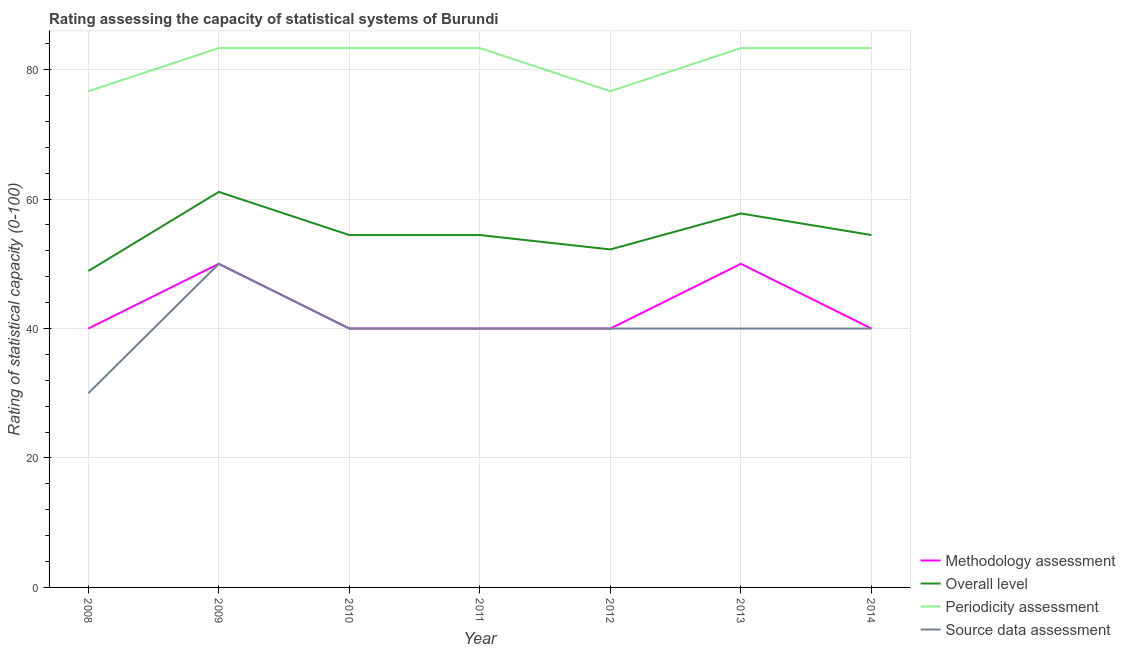How many different coloured lines are there?
Make the answer very short. 4. Does the line corresponding to periodicity assessment rating intersect with the line corresponding to source data assessment rating?
Provide a short and direct response. No. What is the overall level rating in 2012?
Ensure brevity in your answer.  52.22. Across all years, what is the maximum methodology assessment rating?
Offer a terse response. 50. Across all years, what is the minimum source data assessment rating?
Give a very brief answer. 30. In which year was the overall level rating maximum?
Provide a short and direct response. 2009. What is the total methodology assessment rating in the graph?
Provide a succinct answer. 300. What is the difference between the periodicity assessment rating in 2008 and that in 2009?
Keep it short and to the point. -6.67. What is the difference between the source data assessment rating in 2012 and the overall level rating in 2008?
Keep it short and to the point. -8.89. What is the average periodicity assessment rating per year?
Make the answer very short. 81.43. In the year 2008, what is the difference between the source data assessment rating and methodology assessment rating?
Your answer should be compact. -10. In how many years, is the methodology assessment rating greater than 64?
Your response must be concise. 0. Is the source data assessment rating in 2009 less than that in 2011?
Keep it short and to the point. No. What is the difference between the highest and the lowest source data assessment rating?
Your response must be concise. 20. In how many years, is the source data assessment rating greater than the average source data assessment rating taken over all years?
Ensure brevity in your answer.  1. Is it the case that in every year, the sum of the source data assessment rating and methodology assessment rating is greater than the sum of overall level rating and periodicity assessment rating?
Your answer should be very brief. No. Does the overall level rating monotonically increase over the years?
Keep it short and to the point. No. Is the methodology assessment rating strictly greater than the periodicity assessment rating over the years?
Provide a succinct answer. No. Is the overall level rating strictly less than the source data assessment rating over the years?
Make the answer very short. No. Does the graph contain any zero values?
Make the answer very short. No. How many legend labels are there?
Offer a very short reply. 4. What is the title of the graph?
Provide a short and direct response. Rating assessing the capacity of statistical systems of Burundi. Does "Secondary schools" appear as one of the legend labels in the graph?
Your answer should be very brief. No. What is the label or title of the Y-axis?
Offer a very short reply. Rating of statistical capacity (0-100). What is the Rating of statistical capacity (0-100) in Methodology assessment in 2008?
Your answer should be compact. 40. What is the Rating of statistical capacity (0-100) in Overall level in 2008?
Provide a succinct answer. 48.89. What is the Rating of statistical capacity (0-100) in Periodicity assessment in 2008?
Make the answer very short. 76.67. What is the Rating of statistical capacity (0-100) of Overall level in 2009?
Provide a short and direct response. 61.11. What is the Rating of statistical capacity (0-100) in Periodicity assessment in 2009?
Give a very brief answer. 83.33. What is the Rating of statistical capacity (0-100) of Source data assessment in 2009?
Your answer should be compact. 50. What is the Rating of statistical capacity (0-100) of Methodology assessment in 2010?
Your answer should be very brief. 40. What is the Rating of statistical capacity (0-100) of Overall level in 2010?
Provide a short and direct response. 54.44. What is the Rating of statistical capacity (0-100) of Periodicity assessment in 2010?
Offer a very short reply. 83.33. What is the Rating of statistical capacity (0-100) in Source data assessment in 2010?
Your answer should be very brief. 40. What is the Rating of statistical capacity (0-100) in Overall level in 2011?
Provide a succinct answer. 54.44. What is the Rating of statistical capacity (0-100) in Periodicity assessment in 2011?
Offer a very short reply. 83.33. What is the Rating of statistical capacity (0-100) of Source data assessment in 2011?
Offer a terse response. 40. What is the Rating of statistical capacity (0-100) in Methodology assessment in 2012?
Your answer should be very brief. 40. What is the Rating of statistical capacity (0-100) in Overall level in 2012?
Provide a succinct answer. 52.22. What is the Rating of statistical capacity (0-100) in Periodicity assessment in 2012?
Your response must be concise. 76.67. What is the Rating of statistical capacity (0-100) in Source data assessment in 2012?
Give a very brief answer. 40. What is the Rating of statistical capacity (0-100) of Overall level in 2013?
Give a very brief answer. 57.78. What is the Rating of statistical capacity (0-100) in Periodicity assessment in 2013?
Your answer should be compact. 83.33. What is the Rating of statistical capacity (0-100) of Source data assessment in 2013?
Keep it short and to the point. 40. What is the Rating of statistical capacity (0-100) of Overall level in 2014?
Provide a succinct answer. 54.44. What is the Rating of statistical capacity (0-100) in Periodicity assessment in 2014?
Make the answer very short. 83.33. Across all years, what is the maximum Rating of statistical capacity (0-100) in Methodology assessment?
Your answer should be compact. 50. Across all years, what is the maximum Rating of statistical capacity (0-100) of Overall level?
Provide a succinct answer. 61.11. Across all years, what is the maximum Rating of statistical capacity (0-100) in Periodicity assessment?
Give a very brief answer. 83.33. Across all years, what is the maximum Rating of statistical capacity (0-100) in Source data assessment?
Offer a terse response. 50. Across all years, what is the minimum Rating of statistical capacity (0-100) of Overall level?
Ensure brevity in your answer.  48.89. Across all years, what is the minimum Rating of statistical capacity (0-100) of Periodicity assessment?
Ensure brevity in your answer.  76.67. Across all years, what is the minimum Rating of statistical capacity (0-100) of Source data assessment?
Make the answer very short. 30. What is the total Rating of statistical capacity (0-100) in Methodology assessment in the graph?
Ensure brevity in your answer.  300. What is the total Rating of statistical capacity (0-100) of Overall level in the graph?
Make the answer very short. 383.33. What is the total Rating of statistical capacity (0-100) in Periodicity assessment in the graph?
Give a very brief answer. 570. What is the total Rating of statistical capacity (0-100) in Source data assessment in the graph?
Keep it short and to the point. 280. What is the difference between the Rating of statistical capacity (0-100) of Overall level in 2008 and that in 2009?
Give a very brief answer. -12.22. What is the difference between the Rating of statistical capacity (0-100) of Periodicity assessment in 2008 and that in 2009?
Provide a short and direct response. -6.67. What is the difference between the Rating of statistical capacity (0-100) of Source data assessment in 2008 and that in 2009?
Your answer should be very brief. -20. What is the difference between the Rating of statistical capacity (0-100) in Methodology assessment in 2008 and that in 2010?
Provide a succinct answer. 0. What is the difference between the Rating of statistical capacity (0-100) in Overall level in 2008 and that in 2010?
Keep it short and to the point. -5.56. What is the difference between the Rating of statistical capacity (0-100) in Periodicity assessment in 2008 and that in 2010?
Keep it short and to the point. -6.67. What is the difference between the Rating of statistical capacity (0-100) of Source data assessment in 2008 and that in 2010?
Offer a very short reply. -10. What is the difference between the Rating of statistical capacity (0-100) in Methodology assessment in 2008 and that in 2011?
Provide a short and direct response. 0. What is the difference between the Rating of statistical capacity (0-100) of Overall level in 2008 and that in 2011?
Make the answer very short. -5.56. What is the difference between the Rating of statistical capacity (0-100) in Periodicity assessment in 2008 and that in 2011?
Your answer should be very brief. -6.67. What is the difference between the Rating of statistical capacity (0-100) of Methodology assessment in 2008 and that in 2012?
Your answer should be very brief. 0. What is the difference between the Rating of statistical capacity (0-100) of Overall level in 2008 and that in 2012?
Offer a terse response. -3.33. What is the difference between the Rating of statistical capacity (0-100) in Periodicity assessment in 2008 and that in 2012?
Ensure brevity in your answer.  0. What is the difference between the Rating of statistical capacity (0-100) of Methodology assessment in 2008 and that in 2013?
Your response must be concise. -10. What is the difference between the Rating of statistical capacity (0-100) in Overall level in 2008 and that in 2013?
Provide a short and direct response. -8.89. What is the difference between the Rating of statistical capacity (0-100) in Periodicity assessment in 2008 and that in 2013?
Offer a terse response. -6.67. What is the difference between the Rating of statistical capacity (0-100) in Source data assessment in 2008 and that in 2013?
Provide a short and direct response. -10. What is the difference between the Rating of statistical capacity (0-100) of Overall level in 2008 and that in 2014?
Give a very brief answer. -5.56. What is the difference between the Rating of statistical capacity (0-100) of Periodicity assessment in 2008 and that in 2014?
Your answer should be compact. -6.67. What is the difference between the Rating of statistical capacity (0-100) of Source data assessment in 2008 and that in 2014?
Provide a succinct answer. -10. What is the difference between the Rating of statistical capacity (0-100) of Overall level in 2009 and that in 2010?
Offer a very short reply. 6.67. What is the difference between the Rating of statistical capacity (0-100) in Methodology assessment in 2009 and that in 2011?
Keep it short and to the point. 10. What is the difference between the Rating of statistical capacity (0-100) of Overall level in 2009 and that in 2011?
Your answer should be compact. 6.67. What is the difference between the Rating of statistical capacity (0-100) in Periodicity assessment in 2009 and that in 2011?
Provide a short and direct response. 0. What is the difference between the Rating of statistical capacity (0-100) of Source data assessment in 2009 and that in 2011?
Provide a short and direct response. 10. What is the difference between the Rating of statistical capacity (0-100) in Overall level in 2009 and that in 2012?
Provide a short and direct response. 8.89. What is the difference between the Rating of statistical capacity (0-100) in Periodicity assessment in 2009 and that in 2012?
Your answer should be compact. 6.67. What is the difference between the Rating of statistical capacity (0-100) in Source data assessment in 2009 and that in 2012?
Give a very brief answer. 10. What is the difference between the Rating of statistical capacity (0-100) of Overall level in 2009 and that in 2013?
Provide a short and direct response. 3.33. What is the difference between the Rating of statistical capacity (0-100) in Periodicity assessment in 2009 and that in 2013?
Make the answer very short. -0. What is the difference between the Rating of statistical capacity (0-100) in Methodology assessment in 2009 and that in 2014?
Provide a short and direct response. 10. What is the difference between the Rating of statistical capacity (0-100) in Periodicity assessment in 2009 and that in 2014?
Your response must be concise. -0. What is the difference between the Rating of statistical capacity (0-100) in Source data assessment in 2009 and that in 2014?
Offer a very short reply. 10. What is the difference between the Rating of statistical capacity (0-100) of Overall level in 2010 and that in 2011?
Provide a succinct answer. 0. What is the difference between the Rating of statistical capacity (0-100) in Periodicity assessment in 2010 and that in 2011?
Offer a very short reply. 0. What is the difference between the Rating of statistical capacity (0-100) in Source data assessment in 2010 and that in 2011?
Ensure brevity in your answer.  0. What is the difference between the Rating of statistical capacity (0-100) of Methodology assessment in 2010 and that in 2012?
Ensure brevity in your answer.  0. What is the difference between the Rating of statistical capacity (0-100) of Overall level in 2010 and that in 2012?
Provide a short and direct response. 2.22. What is the difference between the Rating of statistical capacity (0-100) of Periodicity assessment in 2010 and that in 2012?
Provide a short and direct response. 6.67. What is the difference between the Rating of statistical capacity (0-100) of Methodology assessment in 2010 and that in 2013?
Your answer should be very brief. -10. What is the difference between the Rating of statistical capacity (0-100) of Periodicity assessment in 2010 and that in 2013?
Give a very brief answer. -0. What is the difference between the Rating of statistical capacity (0-100) of Overall level in 2010 and that in 2014?
Your answer should be compact. 0. What is the difference between the Rating of statistical capacity (0-100) of Periodicity assessment in 2010 and that in 2014?
Offer a very short reply. -0. What is the difference between the Rating of statistical capacity (0-100) in Methodology assessment in 2011 and that in 2012?
Ensure brevity in your answer.  0. What is the difference between the Rating of statistical capacity (0-100) of Overall level in 2011 and that in 2012?
Offer a very short reply. 2.22. What is the difference between the Rating of statistical capacity (0-100) in Source data assessment in 2011 and that in 2012?
Offer a very short reply. 0. What is the difference between the Rating of statistical capacity (0-100) of Overall level in 2011 and that in 2013?
Provide a succinct answer. -3.33. What is the difference between the Rating of statistical capacity (0-100) of Periodicity assessment in 2011 and that in 2013?
Keep it short and to the point. -0. What is the difference between the Rating of statistical capacity (0-100) of Methodology assessment in 2011 and that in 2014?
Your answer should be compact. 0. What is the difference between the Rating of statistical capacity (0-100) in Overall level in 2011 and that in 2014?
Provide a short and direct response. 0. What is the difference between the Rating of statistical capacity (0-100) in Methodology assessment in 2012 and that in 2013?
Your response must be concise. -10. What is the difference between the Rating of statistical capacity (0-100) of Overall level in 2012 and that in 2013?
Your answer should be very brief. -5.56. What is the difference between the Rating of statistical capacity (0-100) in Periodicity assessment in 2012 and that in 2013?
Make the answer very short. -6.67. What is the difference between the Rating of statistical capacity (0-100) of Source data assessment in 2012 and that in 2013?
Keep it short and to the point. 0. What is the difference between the Rating of statistical capacity (0-100) of Methodology assessment in 2012 and that in 2014?
Make the answer very short. 0. What is the difference between the Rating of statistical capacity (0-100) in Overall level in 2012 and that in 2014?
Give a very brief answer. -2.22. What is the difference between the Rating of statistical capacity (0-100) in Periodicity assessment in 2012 and that in 2014?
Your response must be concise. -6.67. What is the difference between the Rating of statistical capacity (0-100) of Overall level in 2013 and that in 2014?
Your answer should be compact. 3.33. What is the difference between the Rating of statistical capacity (0-100) of Periodicity assessment in 2013 and that in 2014?
Provide a succinct answer. 0. What is the difference between the Rating of statistical capacity (0-100) in Source data assessment in 2013 and that in 2014?
Offer a terse response. 0. What is the difference between the Rating of statistical capacity (0-100) in Methodology assessment in 2008 and the Rating of statistical capacity (0-100) in Overall level in 2009?
Offer a very short reply. -21.11. What is the difference between the Rating of statistical capacity (0-100) in Methodology assessment in 2008 and the Rating of statistical capacity (0-100) in Periodicity assessment in 2009?
Make the answer very short. -43.33. What is the difference between the Rating of statistical capacity (0-100) in Overall level in 2008 and the Rating of statistical capacity (0-100) in Periodicity assessment in 2009?
Your answer should be very brief. -34.44. What is the difference between the Rating of statistical capacity (0-100) in Overall level in 2008 and the Rating of statistical capacity (0-100) in Source data assessment in 2009?
Your answer should be very brief. -1.11. What is the difference between the Rating of statistical capacity (0-100) of Periodicity assessment in 2008 and the Rating of statistical capacity (0-100) of Source data assessment in 2009?
Provide a succinct answer. 26.67. What is the difference between the Rating of statistical capacity (0-100) in Methodology assessment in 2008 and the Rating of statistical capacity (0-100) in Overall level in 2010?
Make the answer very short. -14.44. What is the difference between the Rating of statistical capacity (0-100) of Methodology assessment in 2008 and the Rating of statistical capacity (0-100) of Periodicity assessment in 2010?
Your answer should be compact. -43.33. What is the difference between the Rating of statistical capacity (0-100) in Methodology assessment in 2008 and the Rating of statistical capacity (0-100) in Source data assessment in 2010?
Offer a terse response. 0. What is the difference between the Rating of statistical capacity (0-100) in Overall level in 2008 and the Rating of statistical capacity (0-100) in Periodicity assessment in 2010?
Your answer should be very brief. -34.44. What is the difference between the Rating of statistical capacity (0-100) in Overall level in 2008 and the Rating of statistical capacity (0-100) in Source data assessment in 2010?
Your answer should be very brief. 8.89. What is the difference between the Rating of statistical capacity (0-100) in Periodicity assessment in 2008 and the Rating of statistical capacity (0-100) in Source data assessment in 2010?
Your answer should be compact. 36.67. What is the difference between the Rating of statistical capacity (0-100) of Methodology assessment in 2008 and the Rating of statistical capacity (0-100) of Overall level in 2011?
Offer a very short reply. -14.44. What is the difference between the Rating of statistical capacity (0-100) in Methodology assessment in 2008 and the Rating of statistical capacity (0-100) in Periodicity assessment in 2011?
Keep it short and to the point. -43.33. What is the difference between the Rating of statistical capacity (0-100) in Methodology assessment in 2008 and the Rating of statistical capacity (0-100) in Source data assessment in 2011?
Your response must be concise. 0. What is the difference between the Rating of statistical capacity (0-100) in Overall level in 2008 and the Rating of statistical capacity (0-100) in Periodicity assessment in 2011?
Make the answer very short. -34.44. What is the difference between the Rating of statistical capacity (0-100) in Overall level in 2008 and the Rating of statistical capacity (0-100) in Source data assessment in 2011?
Give a very brief answer. 8.89. What is the difference between the Rating of statistical capacity (0-100) in Periodicity assessment in 2008 and the Rating of statistical capacity (0-100) in Source data assessment in 2011?
Your answer should be compact. 36.67. What is the difference between the Rating of statistical capacity (0-100) in Methodology assessment in 2008 and the Rating of statistical capacity (0-100) in Overall level in 2012?
Keep it short and to the point. -12.22. What is the difference between the Rating of statistical capacity (0-100) of Methodology assessment in 2008 and the Rating of statistical capacity (0-100) of Periodicity assessment in 2012?
Ensure brevity in your answer.  -36.67. What is the difference between the Rating of statistical capacity (0-100) of Methodology assessment in 2008 and the Rating of statistical capacity (0-100) of Source data assessment in 2012?
Provide a succinct answer. 0. What is the difference between the Rating of statistical capacity (0-100) in Overall level in 2008 and the Rating of statistical capacity (0-100) in Periodicity assessment in 2012?
Make the answer very short. -27.78. What is the difference between the Rating of statistical capacity (0-100) in Overall level in 2008 and the Rating of statistical capacity (0-100) in Source data assessment in 2012?
Your answer should be very brief. 8.89. What is the difference between the Rating of statistical capacity (0-100) of Periodicity assessment in 2008 and the Rating of statistical capacity (0-100) of Source data assessment in 2012?
Your answer should be compact. 36.67. What is the difference between the Rating of statistical capacity (0-100) of Methodology assessment in 2008 and the Rating of statistical capacity (0-100) of Overall level in 2013?
Offer a very short reply. -17.78. What is the difference between the Rating of statistical capacity (0-100) of Methodology assessment in 2008 and the Rating of statistical capacity (0-100) of Periodicity assessment in 2013?
Provide a succinct answer. -43.33. What is the difference between the Rating of statistical capacity (0-100) of Methodology assessment in 2008 and the Rating of statistical capacity (0-100) of Source data assessment in 2013?
Provide a succinct answer. 0. What is the difference between the Rating of statistical capacity (0-100) in Overall level in 2008 and the Rating of statistical capacity (0-100) in Periodicity assessment in 2013?
Your answer should be compact. -34.44. What is the difference between the Rating of statistical capacity (0-100) of Overall level in 2008 and the Rating of statistical capacity (0-100) of Source data assessment in 2013?
Your response must be concise. 8.89. What is the difference between the Rating of statistical capacity (0-100) of Periodicity assessment in 2008 and the Rating of statistical capacity (0-100) of Source data assessment in 2013?
Offer a very short reply. 36.67. What is the difference between the Rating of statistical capacity (0-100) of Methodology assessment in 2008 and the Rating of statistical capacity (0-100) of Overall level in 2014?
Offer a very short reply. -14.44. What is the difference between the Rating of statistical capacity (0-100) of Methodology assessment in 2008 and the Rating of statistical capacity (0-100) of Periodicity assessment in 2014?
Provide a succinct answer. -43.33. What is the difference between the Rating of statistical capacity (0-100) of Methodology assessment in 2008 and the Rating of statistical capacity (0-100) of Source data assessment in 2014?
Provide a succinct answer. 0. What is the difference between the Rating of statistical capacity (0-100) in Overall level in 2008 and the Rating of statistical capacity (0-100) in Periodicity assessment in 2014?
Provide a short and direct response. -34.44. What is the difference between the Rating of statistical capacity (0-100) in Overall level in 2008 and the Rating of statistical capacity (0-100) in Source data assessment in 2014?
Make the answer very short. 8.89. What is the difference between the Rating of statistical capacity (0-100) in Periodicity assessment in 2008 and the Rating of statistical capacity (0-100) in Source data assessment in 2014?
Give a very brief answer. 36.67. What is the difference between the Rating of statistical capacity (0-100) of Methodology assessment in 2009 and the Rating of statistical capacity (0-100) of Overall level in 2010?
Provide a succinct answer. -4.44. What is the difference between the Rating of statistical capacity (0-100) of Methodology assessment in 2009 and the Rating of statistical capacity (0-100) of Periodicity assessment in 2010?
Your answer should be compact. -33.33. What is the difference between the Rating of statistical capacity (0-100) in Methodology assessment in 2009 and the Rating of statistical capacity (0-100) in Source data assessment in 2010?
Your answer should be compact. 10. What is the difference between the Rating of statistical capacity (0-100) in Overall level in 2009 and the Rating of statistical capacity (0-100) in Periodicity assessment in 2010?
Offer a terse response. -22.22. What is the difference between the Rating of statistical capacity (0-100) in Overall level in 2009 and the Rating of statistical capacity (0-100) in Source data assessment in 2010?
Your answer should be very brief. 21.11. What is the difference between the Rating of statistical capacity (0-100) in Periodicity assessment in 2009 and the Rating of statistical capacity (0-100) in Source data assessment in 2010?
Offer a very short reply. 43.33. What is the difference between the Rating of statistical capacity (0-100) in Methodology assessment in 2009 and the Rating of statistical capacity (0-100) in Overall level in 2011?
Provide a succinct answer. -4.44. What is the difference between the Rating of statistical capacity (0-100) of Methodology assessment in 2009 and the Rating of statistical capacity (0-100) of Periodicity assessment in 2011?
Your answer should be compact. -33.33. What is the difference between the Rating of statistical capacity (0-100) of Overall level in 2009 and the Rating of statistical capacity (0-100) of Periodicity assessment in 2011?
Provide a succinct answer. -22.22. What is the difference between the Rating of statistical capacity (0-100) of Overall level in 2009 and the Rating of statistical capacity (0-100) of Source data assessment in 2011?
Provide a succinct answer. 21.11. What is the difference between the Rating of statistical capacity (0-100) in Periodicity assessment in 2009 and the Rating of statistical capacity (0-100) in Source data assessment in 2011?
Your answer should be compact. 43.33. What is the difference between the Rating of statistical capacity (0-100) of Methodology assessment in 2009 and the Rating of statistical capacity (0-100) of Overall level in 2012?
Make the answer very short. -2.22. What is the difference between the Rating of statistical capacity (0-100) in Methodology assessment in 2009 and the Rating of statistical capacity (0-100) in Periodicity assessment in 2012?
Your answer should be very brief. -26.67. What is the difference between the Rating of statistical capacity (0-100) of Overall level in 2009 and the Rating of statistical capacity (0-100) of Periodicity assessment in 2012?
Your response must be concise. -15.56. What is the difference between the Rating of statistical capacity (0-100) in Overall level in 2009 and the Rating of statistical capacity (0-100) in Source data assessment in 2012?
Offer a very short reply. 21.11. What is the difference between the Rating of statistical capacity (0-100) of Periodicity assessment in 2009 and the Rating of statistical capacity (0-100) of Source data assessment in 2012?
Your answer should be very brief. 43.33. What is the difference between the Rating of statistical capacity (0-100) of Methodology assessment in 2009 and the Rating of statistical capacity (0-100) of Overall level in 2013?
Your answer should be compact. -7.78. What is the difference between the Rating of statistical capacity (0-100) in Methodology assessment in 2009 and the Rating of statistical capacity (0-100) in Periodicity assessment in 2013?
Provide a short and direct response. -33.33. What is the difference between the Rating of statistical capacity (0-100) of Overall level in 2009 and the Rating of statistical capacity (0-100) of Periodicity assessment in 2013?
Provide a succinct answer. -22.22. What is the difference between the Rating of statistical capacity (0-100) of Overall level in 2009 and the Rating of statistical capacity (0-100) of Source data assessment in 2013?
Offer a terse response. 21.11. What is the difference between the Rating of statistical capacity (0-100) of Periodicity assessment in 2009 and the Rating of statistical capacity (0-100) of Source data assessment in 2013?
Offer a terse response. 43.33. What is the difference between the Rating of statistical capacity (0-100) of Methodology assessment in 2009 and the Rating of statistical capacity (0-100) of Overall level in 2014?
Give a very brief answer. -4.44. What is the difference between the Rating of statistical capacity (0-100) of Methodology assessment in 2009 and the Rating of statistical capacity (0-100) of Periodicity assessment in 2014?
Your answer should be very brief. -33.33. What is the difference between the Rating of statistical capacity (0-100) in Methodology assessment in 2009 and the Rating of statistical capacity (0-100) in Source data assessment in 2014?
Provide a short and direct response. 10. What is the difference between the Rating of statistical capacity (0-100) in Overall level in 2009 and the Rating of statistical capacity (0-100) in Periodicity assessment in 2014?
Make the answer very short. -22.22. What is the difference between the Rating of statistical capacity (0-100) in Overall level in 2009 and the Rating of statistical capacity (0-100) in Source data assessment in 2014?
Give a very brief answer. 21.11. What is the difference between the Rating of statistical capacity (0-100) of Periodicity assessment in 2009 and the Rating of statistical capacity (0-100) of Source data assessment in 2014?
Your response must be concise. 43.33. What is the difference between the Rating of statistical capacity (0-100) of Methodology assessment in 2010 and the Rating of statistical capacity (0-100) of Overall level in 2011?
Make the answer very short. -14.44. What is the difference between the Rating of statistical capacity (0-100) of Methodology assessment in 2010 and the Rating of statistical capacity (0-100) of Periodicity assessment in 2011?
Your answer should be very brief. -43.33. What is the difference between the Rating of statistical capacity (0-100) in Overall level in 2010 and the Rating of statistical capacity (0-100) in Periodicity assessment in 2011?
Provide a succinct answer. -28.89. What is the difference between the Rating of statistical capacity (0-100) of Overall level in 2010 and the Rating of statistical capacity (0-100) of Source data assessment in 2011?
Keep it short and to the point. 14.44. What is the difference between the Rating of statistical capacity (0-100) of Periodicity assessment in 2010 and the Rating of statistical capacity (0-100) of Source data assessment in 2011?
Ensure brevity in your answer.  43.33. What is the difference between the Rating of statistical capacity (0-100) in Methodology assessment in 2010 and the Rating of statistical capacity (0-100) in Overall level in 2012?
Your answer should be very brief. -12.22. What is the difference between the Rating of statistical capacity (0-100) in Methodology assessment in 2010 and the Rating of statistical capacity (0-100) in Periodicity assessment in 2012?
Make the answer very short. -36.67. What is the difference between the Rating of statistical capacity (0-100) in Methodology assessment in 2010 and the Rating of statistical capacity (0-100) in Source data assessment in 2012?
Your answer should be compact. 0. What is the difference between the Rating of statistical capacity (0-100) in Overall level in 2010 and the Rating of statistical capacity (0-100) in Periodicity assessment in 2012?
Offer a very short reply. -22.22. What is the difference between the Rating of statistical capacity (0-100) of Overall level in 2010 and the Rating of statistical capacity (0-100) of Source data assessment in 2012?
Keep it short and to the point. 14.44. What is the difference between the Rating of statistical capacity (0-100) in Periodicity assessment in 2010 and the Rating of statistical capacity (0-100) in Source data assessment in 2012?
Offer a very short reply. 43.33. What is the difference between the Rating of statistical capacity (0-100) in Methodology assessment in 2010 and the Rating of statistical capacity (0-100) in Overall level in 2013?
Offer a very short reply. -17.78. What is the difference between the Rating of statistical capacity (0-100) of Methodology assessment in 2010 and the Rating of statistical capacity (0-100) of Periodicity assessment in 2013?
Keep it short and to the point. -43.33. What is the difference between the Rating of statistical capacity (0-100) of Methodology assessment in 2010 and the Rating of statistical capacity (0-100) of Source data assessment in 2013?
Your response must be concise. 0. What is the difference between the Rating of statistical capacity (0-100) of Overall level in 2010 and the Rating of statistical capacity (0-100) of Periodicity assessment in 2013?
Offer a terse response. -28.89. What is the difference between the Rating of statistical capacity (0-100) in Overall level in 2010 and the Rating of statistical capacity (0-100) in Source data assessment in 2013?
Offer a terse response. 14.44. What is the difference between the Rating of statistical capacity (0-100) of Periodicity assessment in 2010 and the Rating of statistical capacity (0-100) of Source data assessment in 2013?
Offer a very short reply. 43.33. What is the difference between the Rating of statistical capacity (0-100) in Methodology assessment in 2010 and the Rating of statistical capacity (0-100) in Overall level in 2014?
Offer a very short reply. -14.44. What is the difference between the Rating of statistical capacity (0-100) in Methodology assessment in 2010 and the Rating of statistical capacity (0-100) in Periodicity assessment in 2014?
Make the answer very short. -43.33. What is the difference between the Rating of statistical capacity (0-100) in Methodology assessment in 2010 and the Rating of statistical capacity (0-100) in Source data assessment in 2014?
Make the answer very short. 0. What is the difference between the Rating of statistical capacity (0-100) in Overall level in 2010 and the Rating of statistical capacity (0-100) in Periodicity assessment in 2014?
Provide a succinct answer. -28.89. What is the difference between the Rating of statistical capacity (0-100) of Overall level in 2010 and the Rating of statistical capacity (0-100) of Source data assessment in 2014?
Keep it short and to the point. 14.44. What is the difference between the Rating of statistical capacity (0-100) of Periodicity assessment in 2010 and the Rating of statistical capacity (0-100) of Source data assessment in 2014?
Provide a succinct answer. 43.33. What is the difference between the Rating of statistical capacity (0-100) in Methodology assessment in 2011 and the Rating of statistical capacity (0-100) in Overall level in 2012?
Make the answer very short. -12.22. What is the difference between the Rating of statistical capacity (0-100) of Methodology assessment in 2011 and the Rating of statistical capacity (0-100) of Periodicity assessment in 2012?
Your answer should be compact. -36.67. What is the difference between the Rating of statistical capacity (0-100) in Overall level in 2011 and the Rating of statistical capacity (0-100) in Periodicity assessment in 2012?
Give a very brief answer. -22.22. What is the difference between the Rating of statistical capacity (0-100) of Overall level in 2011 and the Rating of statistical capacity (0-100) of Source data assessment in 2012?
Your answer should be compact. 14.44. What is the difference between the Rating of statistical capacity (0-100) of Periodicity assessment in 2011 and the Rating of statistical capacity (0-100) of Source data assessment in 2012?
Ensure brevity in your answer.  43.33. What is the difference between the Rating of statistical capacity (0-100) of Methodology assessment in 2011 and the Rating of statistical capacity (0-100) of Overall level in 2013?
Provide a succinct answer. -17.78. What is the difference between the Rating of statistical capacity (0-100) in Methodology assessment in 2011 and the Rating of statistical capacity (0-100) in Periodicity assessment in 2013?
Offer a very short reply. -43.33. What is the difference between the Rating of statistical capacity (0-100) in Overall level in 2011 and the Rating of statistical capacity (0-100) in Periodicity assessment in 2013?
Your response must be concise. -28.89. What is the difference between the Rating of statistical capacity (0-100) of Overall level in 2011 and the Rating of statistical capacity (0-100) of Source data assessment in 2013?
Offer a very short reply. 14.44. What is the difference between the Rating of statistical capacity (0-100) in Periodicity assessment in 2011 and the Rating of statistical capacity (0-100) in Source data assessment in 2013?
Offer a terse response. 43.33. What is the difference between the Rating of statistical capacity (0-100) in Methodology assessment in 2011 and the Rating of statistical capacity (0-100) in Overall level in 2014?
Your answer should be very brief. -14.44. What is the difference between the Rating of statistical capacity (0-100) of Methodology assessment in 2011 and the Rating of statistical capacity (0-100) of Periodicity assessment in 2014?
Provide a succinct answer. -43.33. What is the difference between the Rating of statistical capacity (0-100) in Overall level in 2011 and the Rating of statistical capacity (0-100) in Periodicity assessment in 2014?
Ensure brevity in your answer.  -28.89. What is the difference between the Rating of statistical capacity (0-100) of Overall level in 2011 and the Rating of statistical capacity (0-100) of Source data assessment in 2014?
Provide a succinct answer. 14.44. What is the difference between the Rating of statistical capacity (0-100) in Periodicity assessment in 2011 and the Rating of statistical capacity (0-100) in Source data assessment in 2014?
Your response must be concise. 43.33. What is the difference between the Rating of statistical capacity (0-100) of Methodology assessment in 2012 and the Rating of statistical capacity (0-100) of Overall level in 2013?
Offer a very short reply. -17.78. What is the difference between the Rating of statistical capacity (0-100) of Methodology assessment in 2012 and the Rating of statistical capacity (0-100) of Periodicity assessment in 2013?
Your answer should be very brief. -43.33. What is the difference between the Rating of statistical capacity (0-100) of Methodology assessment in 2012 and the Rating of statistical capacity (0-100) of Source data assessment in 2013?
Your answer should be compact. 0. What is the difference between the Rating of statistical capacity (0-100) of Overall level in 2012 and the Rating of statistical capacity (0-100) of Periodicity assessment in 2013?
Make the answer very short. -31.11. What is the difference between the Rating of statistical capacity (0-100) of Overall level in 2012 and the Rating of statistical capacity (0-100) of Source data assessment in 2013?
Make the answer very short. 12.22. What is the difference between the Rating of statistical capacity (0-100) in Periodicity assessment in 2012 and the Rating of statistical capacity (0-100) in Source data assessment in 2013?
Offer a terse response. 36.67. What is the difference between the Rating of statistical capacity (0-100) of Methodology assessment in 2012 and the Rating of statistical capacity (0-100) of Overall level in 2014?
Keep it short and to the point. -14.44. What is the difference between the Rating of statistical capacity (0-100) in Methodology assessment in 2012 and the Rating of statistical capacity (0-100) in Periodicity assessment in 2014?
Offer a very short reply. -43.33. What is the difference between the Rating of statistical capacity (0-100) of Methodology assessment in 2012 and the Rating of statistical capacity (0-100) of Source data assessment in 2014?
Make the answer very short. 0. What is the difference between the Rating of statistical capacity (0-100) of Overall level in 2012 and the Rating of statistical capacity (0-100) of Periodicity assessment in 2014?
Your answer should be compact. -31.11. What is the difference between the Rating of statistical capacity (0-100) in Overall level in 2012 and the Rating of statistical capacity (0-100) in Source data assessment in 2014?
Make the answer very short. 12.22. What is the difference between the Rating of statistical capacity (0-100) of Periodicity assessment in 2012 and the Rating of statistical capacity (0-100) of Source data assessment in 2014?
Offer a very short reply. 36.67. What is the difference between the Rating of statistical capacity (0-100) in Methodology assessment in 2013 and the Rating of statistical capacity (0-100) in Overall level in 2014?
Offer a terse response. -4.44. What is the difference between the Rating of statistical capacity (0-100) in Methodology assessment in 2013 and the Rating of statistical capacity (0-100) in Periodicity assessment in 2014?
Provide a short and direct response. -33.33. What is the difference between the Rating of statistical capacity (0-100) of Overall level in 2013 and the Rating of statistical capacity (0-100) of Periodicity assessment in 2014?
Offer a very short reply. -25.56. What is the difference between the Rating of statistical capacity (0-100) of Overall level in 2013 and the Rating of statistical capacity (0-100) of Source data assessment in 2014?
Make the answer very short. 17.78. What is the difference between the Rating of statistical capacity (0-100) in Periodicity assessment in 2013 and the Rating of statistical capacity (0-100) in Source data assessment in 2014?
Offer a terse response. 43.33. What is the average Rating of statistical capacity (0-100) in Methodology assessment per year?
Offer a terse response. 42.86. What is the average Rating of statistical capacity (0-100) of Overall level per year?
Offer a terse response. 54.76. What is the average Rating of statistical capacity (0-100) of Periodicity assessment per year?
Your response must be concise. 81.43. What is the average Rating of statistical capacity (0-100) of Source data assessment per year?
Keep it short and to the point. 40. In the year 2008, what is the difference between the Rating of statistical capacity (0-100) of Methodology assessment and Rating of statistical capacity (0-100) of Overall level?
Your answer should be very brief. -8.89. In the year 2008, what is the difference between the Rating of statistical capacity (0-100) of Methodology assessment and Rating of statistical capacity (0-100) of Periodicity assessment?
Your response must be concise. -36.67. In the year 2008, what is the difference between the Rating of statistical capacity (0-100) in Methodology assessment and Rating of statistical capacity (0-100) in Source data assessment?
Your response must be concise. 10. In the year 2008, what is the difference between the Rating of statistical capacity (0-100) of Overall level and Rating of statistical capacity (0-100) of Periodicity assessment?
Your answer should be very brief. -27.78. In the year 2008, what is the difference between the Rating of statistical capacity (0-100) in Overall level and Rating of statistical capacity (0-100) in Source data assessment?
Your response must be concise. 18.89. In the year 2008, what is the difference between the Rating of statistical capacity (0-100) of Periodicity assessment and Rating of statistical capacity (0-100) of Source data assessment?
Your answer should be compact. 46.67. In the year 2009, what is the difference between the Rating of statistical capacity (0-100) of Methodology assessment and Rating of statistical capacity (0-100) of Overall level?
Offer a terse response. -11.11. In the year 2009, what is the difference between the Rating of statistical capacity (0-100) in Methodology assessment and Rating of statistical capacity (0-100) in Periodicity assessment?
Offer a terse response. -33.33. In the year 2009, what is the difference between the Rating of statistical capacity (0-100) of Methodology assessment and Rating of statistical capacity (0-100) of Source data assessment?
Your response must be concise. 0. In the year 2009, what is the difference between the Rating of statistical capacity (0-100) of Overall level and Rating of statistical capacity (0-100) of Periodicity assessment?
Make the answer very short. -22.22. In the year 2009, what is the difference between the Rating of statistical capacity (0-100) in Overall level and Rating of statistical capacity (0-100) in Source data assessment?
Offer a very short reply. 11.11. In the year 2009, what is the difference between the Rating of statistical capacity (0-100) of Periodicity assessment and Rating of statistical capacity (0-100) of Source data assessment?
Give a very brief answer. 33.33. In the year 2010, what is the difference between the Rating of statistical capacity (0-100) in Methodology assessment and Rating of statistical capacity (0-100) in Overall level?
Keep it short and to the point. -14.44. In the year 2010, what is the difference between the Rating of statistical capacity (0-100) of Methodology assessment and Rating of statistical capacity (0-100) of Periodicity assessment?
Your response must be concise. -43.33. In the year 2010, what is the difference between the Rating of statistical capacity (0-100) of Methodology assessment and Rating of statistical capacity (0-100) of Source data assessment?
Make the answer very short. 0. In the year 2010, what is the difference between the Rating of statistical capacity (0-100) of Overall level and Rating of statistical capacity (0-100) of Periodicity assessment?
Offer a very short reply. -28.89. In the year 2010, what is the difference between the Rating of statistical capacity (0-100) in Overall level and Rating of statistical capacity (0-100) in Source data assessment?
Your answer should be compact. 14.44. In the year 2010, what is the difference between the Rating of statistical capacity (0-100) in Periodicity assessment and Rating of statistical capacity (0-100) in Source data assessment?
Ensure brevity in your answer.  43.33. In the year 2011, what is the difference between the Rating of statistical capacity (0-100) in Methodology assessment and Rating of statistical capacity (0-100) in Overall level?
Offer a terse response. -14.44. In the year 2011, what is the difference between the Rating of statistical capacity (0-100) in Methodology assessment and Rating of statistical capacity (0-100) in Periodicity assessment?
Your answer should be compact. -43.33. In the year 2011, what is the difference between the Rating of statistical capacity (0-100) of Overall level and Rating of statistical capacity (0-100) of Periodicity assessment?
Make the answer very short. -28.89. In the year 2011, what is the difference between the Rating of statistical capacity (0-100) in Overall level and Rating of statistical capacity (0-100) in Source data assessment?
Offer a very short reply. 14.44. In the year 2011, what is the difference between the Rating of statistical capacity (0-100) of Periodicity assessment and Rating of statistical capacity (0-100) of Source data assessment?
Give a very brief answer. 43.33. In the year 2012, what is the difference between the Rating of statistical capacity (0-100) in Methodology assessment and Rating of statistical capacity (0-100) in Overall level?
Your response must be concise. -12.22. In the year 2012, what is the difference between the Rating of statistical capacity (0-100) of Methodology assessment and Rating of statistical capacity (0-100) of Periodicity assessment?
Your response must be concise. -36.67. In the year 2012, what is the difference between the Rating of statistical capacity (0-100) of Overall level and Rating of statistical capacity (0-100) of Periodicity assessment?
Ensure brevity in your answer.  -24.44. In the year 2012, what is the difference between the Rating of statistical capacity (0-100) in Overall level and Rating of statistical capacity (0-100) in Source data assessment?
Your answer should be very brief. 12.22. In the year 2012, what is the difference between the Rating of statistical capacity (0-100) in Periodicity assessment and Rating of statistical capacity (0-100) in Source data assessment?
Provide a short and direct response. 36.67. In the year 2013, what is the difference between the Rating of statistical capacity (0-100) of Methodology assessment and Rating of statistical capacity (0-100) of Overall level?
Ensure brevity in your answer.  -7.78. In the year 2013, what is the difference between the Rating of statistical capacity (0-100) in Methodology assessment and Rating of statistical capacity (0-100) in Periodicity assessment?
Offer a terse response. -33.33. In the year 2013, what is the difference between the Rating of statistical capacity (0-100) of Methodology assessment and Rating of statistical capacity (0-100) of Source data assessment?
Keep it short and to the point. 10. In the year 2013, what is the difference between the Rating of statistical capacity (0-100) of Overall level and Rating of statistical capacity (0-100) of Periodicity assessment?
Keep it short and to the point. -25.56. In the year 2013, what is the difference between the Rating of statistical capacity (0-100) of Overall level and Rating of statistical capacity (0-100) of Source data assessment?
Offer a terse response. 17.78. In the year 2013, what is the difference between the Rating of statistical capacity (0-100) in Periodicity assessment and Rating of statistical capacity (0-100) in Source data assessment?
Keep it short and to the point. 43.33. In the year 2014, what is the difference between the Rating of statistical capacity (0-100) of Methodology assessment and Rating of statistical capacity (0-100) of Overall level?
Provide a succinct answer. -14.44. In the year 2014, what is the difference between the Rating of statistical capacity (0-100) in Methodology assessment and Rating of statistical capacity (0-100) in Periodicity assessment?
Provide a succinct answer. -43.33. In the year 2014, what is the difference between the Rating of statistical capacity (0-100) of Methodology assessment and Rating of statistical capacity (0-100) of Source data assessment?
Your answer should be very brief. 0. In the year 2014, what is the difference between the Rating of statistical capacity (0-100) of Overall level and Rating of statistical capacity (0-100) of Periodicity assessment?
Ensure brevity in your answer.  -28.89. In the year 2014, what is the difference between the Rating of statistical capacity (0-100) of Overall level and Rating of statistical capacity (0-100) of Source data assessment?
Your response must be concise. 14.44. In the year 2014, what is the difference between the Rating of statistical capacity (0-100) in Periodicity assessment and Rating of statistical capacity (0-100) in Source data assessment?
Ensure brevity in your answer.  43.33. What is the ratio of the Rating of statistical capacity (0-100) in Overall level in 2008 to that in 2009?
Offer a terse response. 0.8. What is the ratio of the Rating of statistical capacity (0-100) in Source data assessment in 2008 to that in 2009?
Offer a terse response. 0.6. What is the ratio of the Rating of statistical capacity (0-100) in Methodology assessment in 2008 to that in 2010?
Your answer should be very brief. 1. What is the ratio of the Rating of statistical capacity (0-100) in Overall level in 2008 to that in 2010?
Provide a succinct answer. 0.9. What is the ratio of the Rating of statistical capacity (0-100) in Periodicity assessment in 2008 to that in 2010?
Ensure brevity in your answer.  0.92. What is the ratio of the Rating of statistical capacity (0-100) in Methodology assessment in 2008 to that in 2011?
Offer a very short reply. 1. What is the ratio of the Rating of statistical capacity (0-100) in Overall level in 2008 to that in 2011?
Your answer should be very brief. 0.9. What is the ratio of the Rating of statistical capacity (0-100) of Source data assessment in 2008 to that in 2011?
Provide a short and direct response. 0.75. What is the ratio of the Rating of statistical capacity (0-100) of Methodology assessment in 2008 to that in 2012?
Offer a terse response. 1. What is the ratio of the Rating of statistical capacity (0-100) of Overall level in 2008 to that in 2012?
Make the answer very short. 0.94. What is the ratio of the Rating of statistical capacity (0-100) of Overall level in 2008 to that in 2013?
Provide a succinct answer. 0.85. What is the ratio of the Rating of statistical capacity (0-100) of Source data assessment in 2008 to that in 2013?
Your response must be concise. 0.75. What is the ratio of the Rating of statistical capacity (0-100) of Overall level in 2008 to that in 2014?
Your response must be concise. 0.9. What is the ratio of the Rating of statistical capacity (0-100) in Periodicity assessment in 2008 to that in 2014?
Your response must be concise. 0.92. What is the ratio of the Rating of statistical capacity (0-100) of Source data assessment in 2008 to that in 2014?
Keep it short and to the point. 0.75. What is the ratio of the Rating of statistical capacity (0-100) of Methodology assessment in 2009 to that in 2010?
Ensure brevity in your answer.  1.25. What is the ratio of the Rating of statistical capacity (0-100) in Overall level in 2009 to that in 2010?
Provide a succinct answer. 1.12. What is the ratio of the Rating of statistical capacity (0-100) in Overall level in 2009 to that in 2011?
Provide a short and direct response. 1.12. What is the ratio of the Rating of statistical capacity (0-100) in Periodicity assessment in 2009 to that in 2011?
Your answer should be very brief. 1. What is the ratio of the Rating of statistical capacity (0-100) of Source data assessment in 2009 to that in 2011?
Your answer should be very brief. 1.25. What is the ratio of the Rating of statistical capacity (0-100) of Methodology assessment in 2009 to that in 2012?
Keep it short and to the point. 1.25. What is the ratio of the Rating of statistical capacity (0-100) in Overall level in 2009 to that in 2012?
Ensure brevity in your answer.  1.17. What is the ratio of the Rating of statistical capacity (0-100) of Periodicity assessment in 2009 to that in 2012?
Your response must be concise. 1.09. What is the ratio of the Rating of statistical capacity (0-100) of Source data assessment in 2009 to that in 2012?
Keep it short and to the point. 1.25. What is the ratio of the Rating of statistical capacity (0-100) in Methodology assessment in 2009 to that in 2013?
Offer a terse response. 1. What is the ratio of the Rating of statistical capacity (0-100) in Overall level in 2009 to that in 2013?
Give a very brief answer. 1.06. What is the ratio of the Rating of statistical capacity (0-100) of Methodology assessment in 2009 to that in 2014?
Your answer should be very brief. 1.25. What is the ratio of the Rating of statistical capacity (0-100) of Overall level in 2009 to that in 2014?
Offer a very short reply. 1.12. What is the ratio of the Rating of statistical capacity (0-100) in Periodicity assessment in 2009 to that in 2014?
Provide a short and direct response. 1. What is the ratio of the Rating of statistical capacity (0-100) in Overall level in 2010 to that in 2012?
Provide a short and direct response. 1.04. What is the ratio of the Rating of statistical capacity (0-100) in Periodicity assessment in 2010 to that in 2012?
Give a very brief answer. 1.09. What is the ratio of the Rating of statistical capacity (0-100) of Source data assessment in 2010 to that in 2012?
Give a very brief answer. 1. What is the ratio of the Rating of statistical capacity (0-100) of Methodology assessment in 2010 to that in 2013?
Your answer should be compact. 0.8. What is the ratio of the Rating of statistical capacity (0-100) of Overall level in 2010 to that in 2013?
Provide a short and direct response. 0.94. What is the ratio of the Rating of statistical capacity (0-100) in Periodicity assessment in 2010 to that in 2013?
Provide a short and direct response. 1. What is the ratio of the Rating of statistical capacity (0-100) in Methodology assessment in 2010 to that in 2014?
Make the answer very short. 1. What is the ratio of the Rating of statistical capacity (0-100) in Overall level in 2010 to that in 2014?
Your answer should be very brief. 1. What is the ratio of the Rating of statistical capacity (0-100) of Periodicity assessment in 2010 to that in 2014?
Your response must be concise. 1. What is the ratio of the Rating of statistical capacity (0-100) of Source data assessment in 2010 to that in 2014?
Your response must be concise. 1. What is the ratio of the Rating of statistical capacity (0-100) in Overall level in 2011 to that in 2012?
Provide a succinct answer. 1.04. What is the ratio of the Rating of statistical capacity (0-100) in Periodicity assessment in 2011 to that in 2012?
Provide a short and direct response. 1.09. What is the ratio of the Rating of statistical capacity (0-100) in Source data assessment in 2011 to that in 2012?
Offer a terse response. 1. What is the ratio of the Rating of statistical capacity (0-100) of Overall level in 2011 to that in 2013?
Your response must be concise. 0.94. What is the ratio of the Rating of statistical capacity (0-100) in Periodicity assessment in 2011 to that in 2013?
Give a very brief answer. 1. What is the ratio of the Rating of statistical capacity (0-100) in Source data assessment in 2011 to that in 2013?
Offer a terse response. 1. What is the ratio of the Rating of statistical capacity (0-100) of Methodology assessment in 2011 to that in 2014?
Provide a succinct answer. 1. What is the ratio of the Rating of statistical capacity (0-100) of Periodicity assessment in 2011 to that in 2014?
Keep it short and to the point. 1. What is the ratio of the Rating of statistical capacity (0-100) in Overall level in 2012 to that in 2013?
Offer a terse response. 0.9. What is the ratio of the Rating of statistical capacity (0-100) of Overall level in 2012 to that in 2014?
Your response must be concise. 0.96. What is the ratio of the Rating of statistical capacity (0-100) of Periodicity assessment in 2012 to that in 2014?
Offer a very short reply. 0.92. What is the ratio of the Rating of statistical capacity (0-100) of Source data assessment in 2012 to that in 2014?
Your answer should be very brief. 1. What is the ratio of the Rating of statistical capacity (0-100) in Overall level in 2013 to that in 2014?
Your answer should be very brief. 1.06. What is the difference between the highest and the second highest Rating of statistical capacity (0-100) of Methodology assessment?
Ensure brevity in your answer.  0. What is the difference between the highest and the second highest Rating of statistical capacity (0-100) in Overall level?
Your answer should be very brief. 3.33. What is the difference between the highest and the second highest Rating of statistical capacity (0-100) of Source data assessment?
Make the answer very short. 10. What is the difference between the highest and the lowest Rating of statistical capacity (0-100) of Methodology assessment?
Your answer should be very brief. 10. What is the difference between the highest and the lowest Rating of statistical capacity (0-100) in Overall level?
Provide a succinct answer. 12.22. 